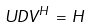<formula> <loc_0><loc_0><loc_500><loc_500>U D V ^ { H } \, = \, H</formula> 